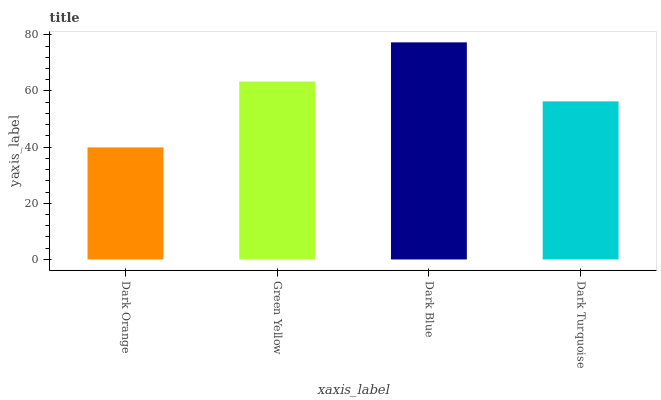Is Green Yellow the minimum?
Answer yes or no. No. Is Green Yellow the maximum?
Answer yes or no. No. Is Green Yellow greater than Dark Orange?
Answer yes or no. Yes. Is Dark Orange less than Green Yellow?
Answer yes or no. Yes. Is Dark Orange greater than Green Yellow?
Answer yes or no. No. Is Green Yellow less than Dark Orange?
Answer yes or no. No. Is Green Yellow the high median?
Answer yes or no. Yes. Is Dark Turquoise the low median?
Answer yes or no. Yes. Is Dark Turquoise the high median?
Answer yes or no. No. Is Dark Orange the low median?
Answer yes or no. No. 